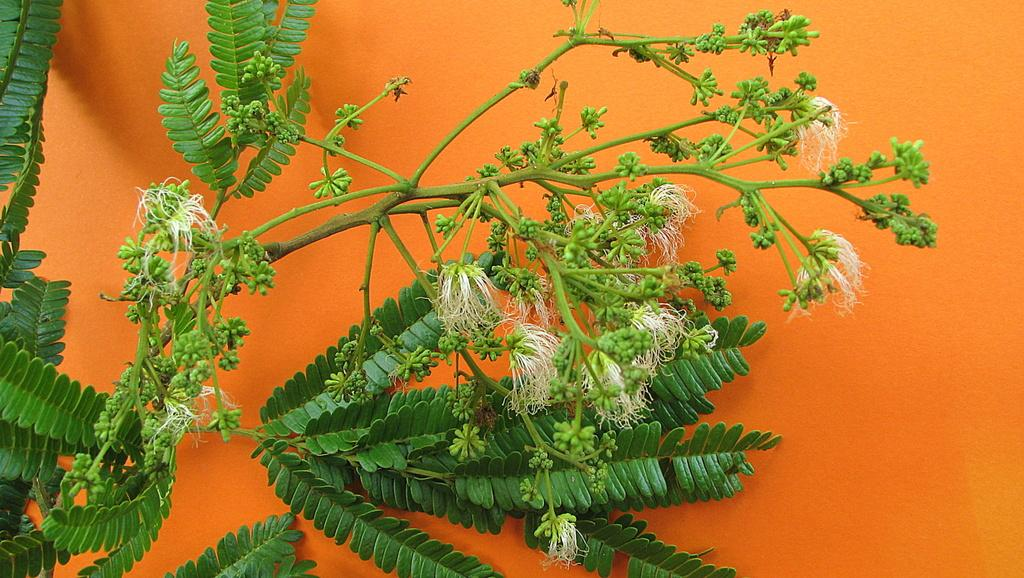What type of living organism can be seen in the image? There is a plant in the image. What color is the wall in the image? There is an orange-colored wall in the image. How many hats are hanging on the orange-colored wall in the image? There are no hats present in the image. What type of spiders can be seen crawling on the plant in the image? There are no spiders present in the image. 